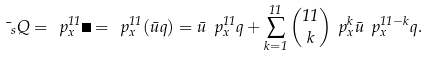Convert formula to latex. <formula><loc_0><loc_0><loc_500><loc_500>\mu _ { s } Q = \ p _ { x } ^ { 1 1 } \psi = \ p _ { x } ^ { 1 1 } ( \bar { u } q ) = \bar { u } \ p _ { x } ^ { 1 1 } q + \sum _ { k = 1 } ^ { 1 1 } \binom { 1 1 } { k } \ p _ { x } ^ { k } \bar { u } \ p _ { x } ^ { 1 1 - k } q .</formula> 